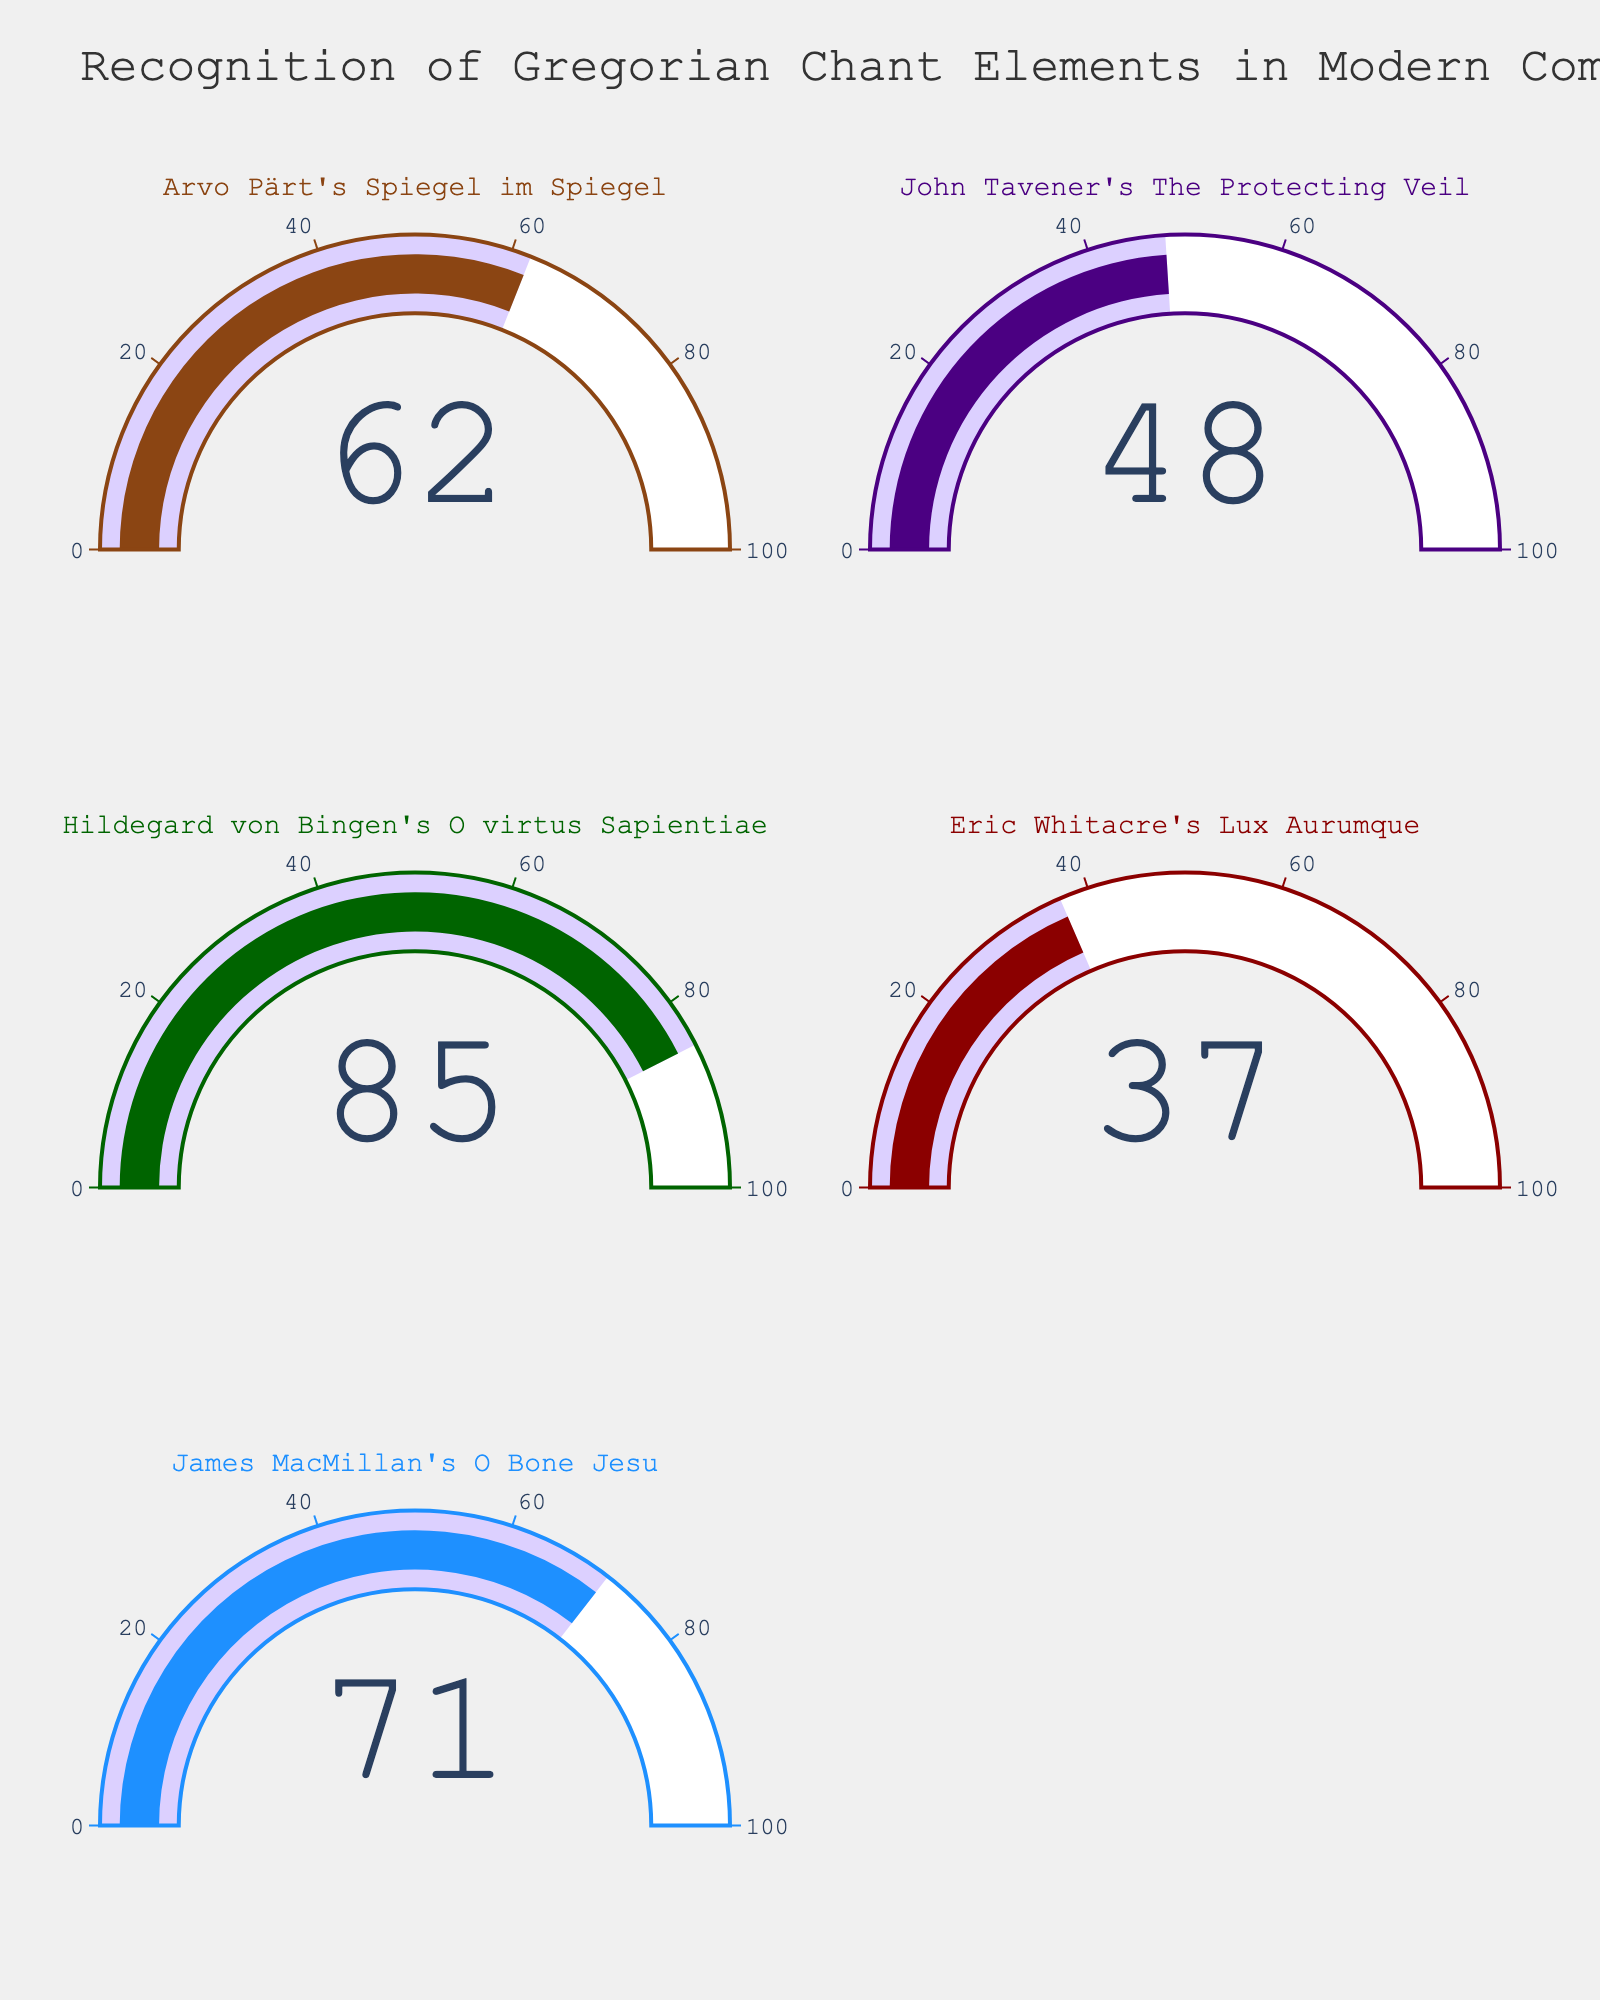What’s the recognition percentage for "Eric Whitacre's Lux Aurumque"? Look at the gauge chart, find the gauge corresponding to "Eric Whitacre's Lux Aurumque" and read the displayed number.
Answer: 37% How many compositions have a recognition percentage greater than 50%? Identify each gauge where the recognition percentage is greater than 50% and count them.
Answer: 3 Which composition has the highest recognition percentage? Compare the recognition percentages among all gauges and identify the composition with the highest value.
Answer: "Hildegard von Bingen's O virtus Sapientiae" What's the average recognition percentage of all compositions? Sum the recognition percentages of all compositions and divide by the number of compositions: (62 + 48 + 85 + 37 + 71) / 5 = 303 / 5 = 60.6
Answer: 60.6 Which color corresponds to "James MacMillan's O Bone Jesu"? Find the gauge for "James MacMillan's O Bone Jesu" and note the color used for its bar and border.
Answer: Blue What is the total recognition percentage for "Arvo Pärt's Spiegel im Spiegel" and "John Tavener's The Protecting Veil"? Sum the recognition percentages for "Arvo Pärt's Spiegel im Spiegel" and "John Tavener's The Protecting Veil": 62 + 48 = 110
Answer: 110 Compare the recognition percentages of "Hildegard von Bingen's O virtus Sapientiae" and "Eric Whitacre's Lux Aurumque". Which one is higher? Look at the gauges for both compositions and compare their recognition percentages. "Hildegard von Bingen's O virtus Sapientiae" has a higher percentage (85) compared to "Eric Whitacre's Lux Aurumque" (37).
Answer: "Hildegard von Bingen's O virtus Sapientiae" What's the difference in recognition percentage between "James MacMillan's O Bone Jesu" and "John Tavener's The Protecting Veil"? Subtract the recognition percentage of "John Tavener's The Protecting Veil" from that of "James MacMillan's O Bone Jesu": 71 - 48 = 23
Answer: 23 How many compositions are analyzed in the figure? Count the number of gauges displayed, as each represents one composition.
Answer: 5 